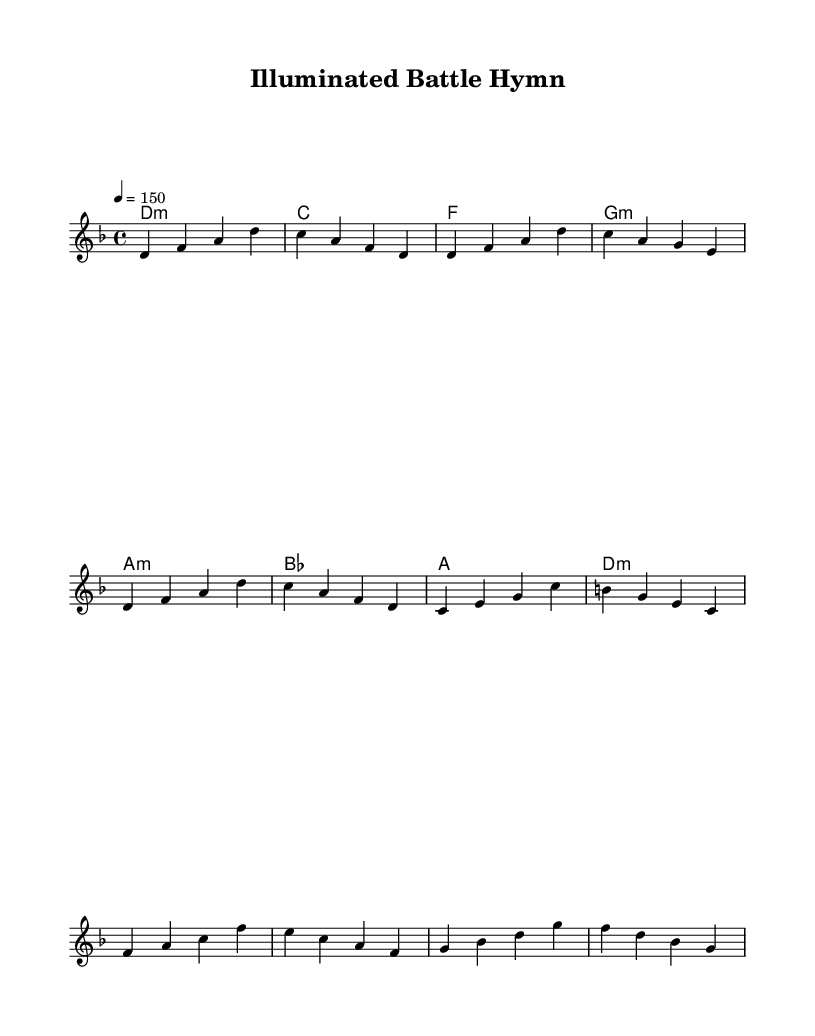What is the key signature of this music? The key signature indicates the key of D minor, which has one flat (B flat). This can be determined from the key signature note displayed at the beginning of the staff.
Answer: D minor What is the time signature of this music? The time signature is 4/4, often indicated at the beginning of the score. This means there are four beats in each measure and a quarter note gets one beat.
Answer: 4/4 What is the tempo marking for this piece? The tempo marking is given as a metronome marking of 150, indicating that there should be 150 beats per minute. This information is often found near the start of the score under the global directives.
Answer: 150 How many measures are in the melody? To find the number of measures, we count the individual measure segments represented between vertical bar lines in the melody part. There are a total of 8 measures in the melody section provided.
Answer: 8 What is the chord progression for the chorus? The chord progression shows the sequence of chords played during the chorus, indicated under the rhythmic structure marked as "Chorus". The sequence is: F, A minor, G minor, D minor.
Answer: F, A minor, G minor, D minor Which instruments are present in the score? This score contains a "lead" voice part, which suggests that it is for a melodic instrument. Additionally, there are chord names for harmony with a specified part for string instruments like guitars. Thus, the primary instrument would likely be guitar with potential vocal accompaniment.
Answer: Lead voice and chord instrument (guitar) What is the mood suggested by the key and tempo? D minor is often associated with somber or introspective emotions, and combined with the fast tempo of 150, the mood can be interpreted as intense and powerful, fitting the Viking metal style. The combination of key and tempo creates a contrast that gives a sense of urgency and strength typical in heavy metal music.
Answer: Intense and powerful 